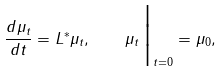<formula> <loc_0><loc_0><loc_500><loc_500>\frac { d \mu _ { t } } { d t } = L ^ { * } \mu _ { t } , \quad \mu _ { t } \, \Big | _ { t = 0 } = \mu _ { 0 } ,</formula> 